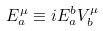<formula> <loc_0><loc_0><loc_500><loc_500>E ^ { \mu } _ { a } \equiv i E ^ { b } _ { a } V ^ { \mu } _ { b }</formula> 